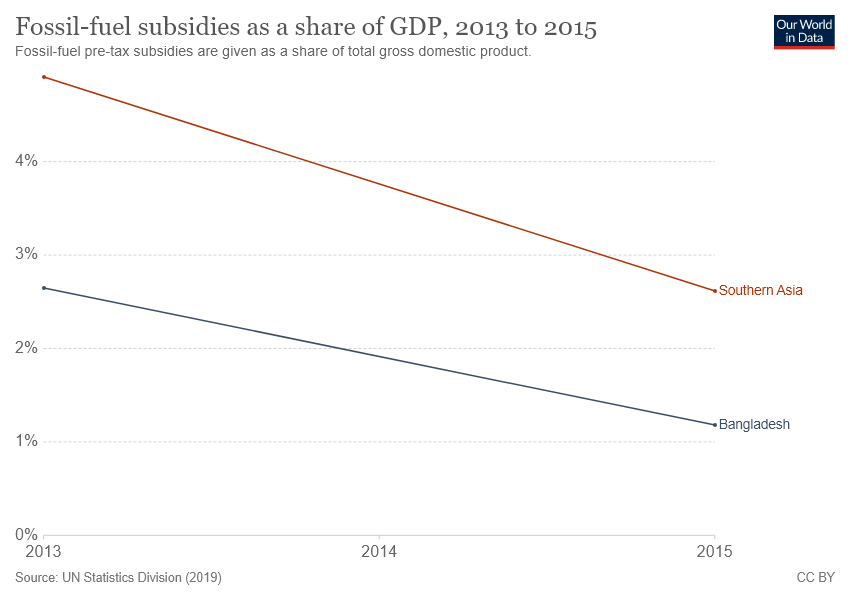Point out several critical features in this image. In 2015, the difference in fossil-fuel subsidies between Southern Asia and Bangladesh was at its lowest point. Southern Asia has been reported to receive the highest amount of fossil-fuel subsidies among all regions in the world. 